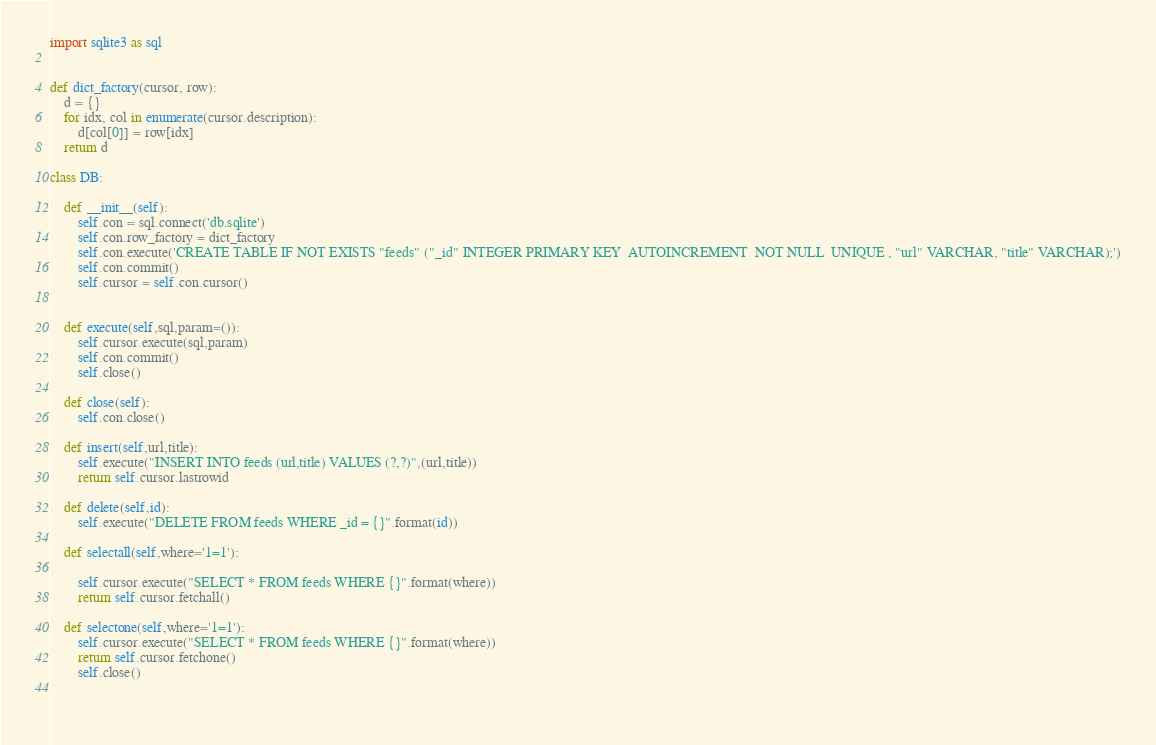Convert code to text. <code><loc_0><loc_0><loc_500><loc_500><_Python_>import sqlite3 as sql


def dict_factory(cursor, row):
    d = {}
    for idx, col in enumerate(cursor.description):
        d[col[0]] = row[idx]
    return d
    
class DB:
    
    def __init__(self):
        self.con = sql.connect('db.sqlite')
        self.con.row_factory = dict_factory
        self.con.execute('CREATE TABLE IF NOT EXISTS "feeds" ("_id" INTEGER PRIMARY KEY  AUTOINCREMENT  NOT NULL  UNIQUE , "url" VARCHAR, "title" VARCHAR);')
        self.con.commit()
        self.cursor = self.con.cursor()
        
        
    def execute(self,sql,param=()):
        self.cursor.execute(sql,param)
        self.con.commit()
        self.close()
    
    def close(self):
        self.con.close()    
        
    def insert(self,url,title):
        self.execute("INSERT INTO feeds (url,title) VALUES (?,?)",(url,title))
        return self.cursor.lastrowid

    def delete(self,id):
        self.execute("DELETE FROM feeds WHERE _id = {}".format(id))    

    def selectall(self,where='1=1'):
        
        self.cursor.execute("SELECT * FROM feeds WHERE {}".format(where))
        return self.cursor.fetchall()

    def selectone(self,where='1=1'):
        self.cursor.execute("SELECT * FROM feeds WHERE {}".format(where))
        return self.cursor.fetchone()
        self.close()
    
    </code> 